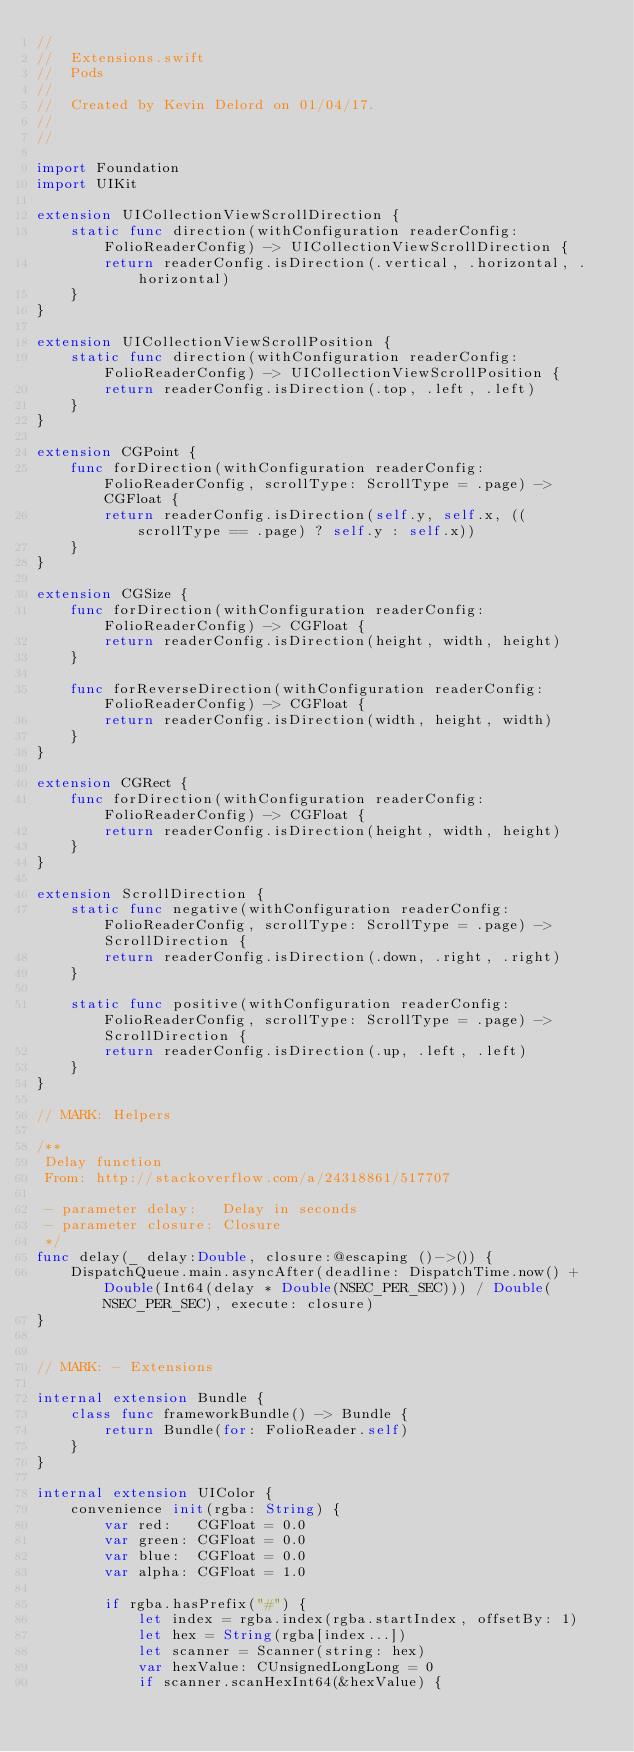Convert code to text. <code><loc_0><loc_0><loc_500><loc_500><_Swift_>//
//  Extensions.swift
//  Pods
//
//  Created by Kevin Delord on 01/04/17.
//
//

import Foundation
import UIKit

extension UICollectionViewScrollDirection {
    static func direction(withConfiguration readerConfig: FolioReaderConfig) -> UICollectionViewScrollDirection {
        return readerConfig.isDirection(.vertical, .horizontal, .horizontal)
    }
}

extension UICollectionViewScrollPosition {
    static func direction(withConfiguration readerConfig: FolioReaderConfig) -> UICollectionViewScrollPosition {
        return readerConfig.isDirection(.top, .left, .left)
    }
}

extension CGPoint {
    func forDirection(withConfiguration readerConfig: FolioReaderConfig, scrollType: ScrollType = .page) -> CGFloat {
        return readerConfig.isDirection(self.y, self.x, ((scrollType == .page) ? self.y : self.x))
    }
}

extension CGSize {
    func forDirection(withConfiguration readerConfig: FolioReaderConfig) -> CGFloat {
        return readerConfig.isDirection(height, width, height)
    }

    func forReverseDirection(withConfiguration readerConfig: FolioReaderConfig) -> CGFloat {
        return readerConfig.isDirection(width, height, width)
    }
}

extension CGRect {
    func forDirection(withConfiguration readerConfig: FolioReaderConfig) -> CGFloat {
        return readerConfig.isDirection(height, width, height)
    }
}

extension ScrollDirection {
    static func negative(withConfiguration readerConfig: FolioReaderConfig, scrollType: ScrollType = .page) -> ScrollDirection {
        return readerConfig.isDirection(.down, .right, .right)
    }

    static func positive(withConfiguration readerConfig: FolioReaderConfig, scrollType: ScrollType = .page) -> ScrollDirection {
        return readerConfig.isDirection(.up, .left, .left)
    }
}

// MARK: Helpers

/**
 Delay function
 From: http://stackoverflow.com/a/24318861/517707

 - parameter delay:   Delay in seconds
 - parameter closure: Closure
 */
func delay(_ delay:Double, closure:@escaping ()->()) {
    DispatchQueue.main.asyncAfter(deadline: DispatchTime.now() + Double(Int64(delay * Double(NSEC_PER_SEC))) / Double(NSEC_PER_SEC), execute: closure)
}


// MARK: - Extensions

internal extension Bundle {
    class func frameworkBundle() -> Bundle {
        return Bundle(for: FolioReader.self)
    }
}

internal extension UIColor {
    convenience init(rgba: String) {
        var red:   CGFloat = 0.0
        var green: CGFloat = 0.0
        var blue:  CGFloat = 0.0
        var alpha: CGFloat = 1.0

        if rgba.hasPrefix("#") {
            let index = rgba.index(rgba.startIndex, offsetBy: 1)
            let hex = String(rgba[index...])
            let scanner = Scanner(string: hex)
            var hexValue: CUnsignedLongLong = 0
            if scanner.scanHexInt64(&hexValue) {</code> 